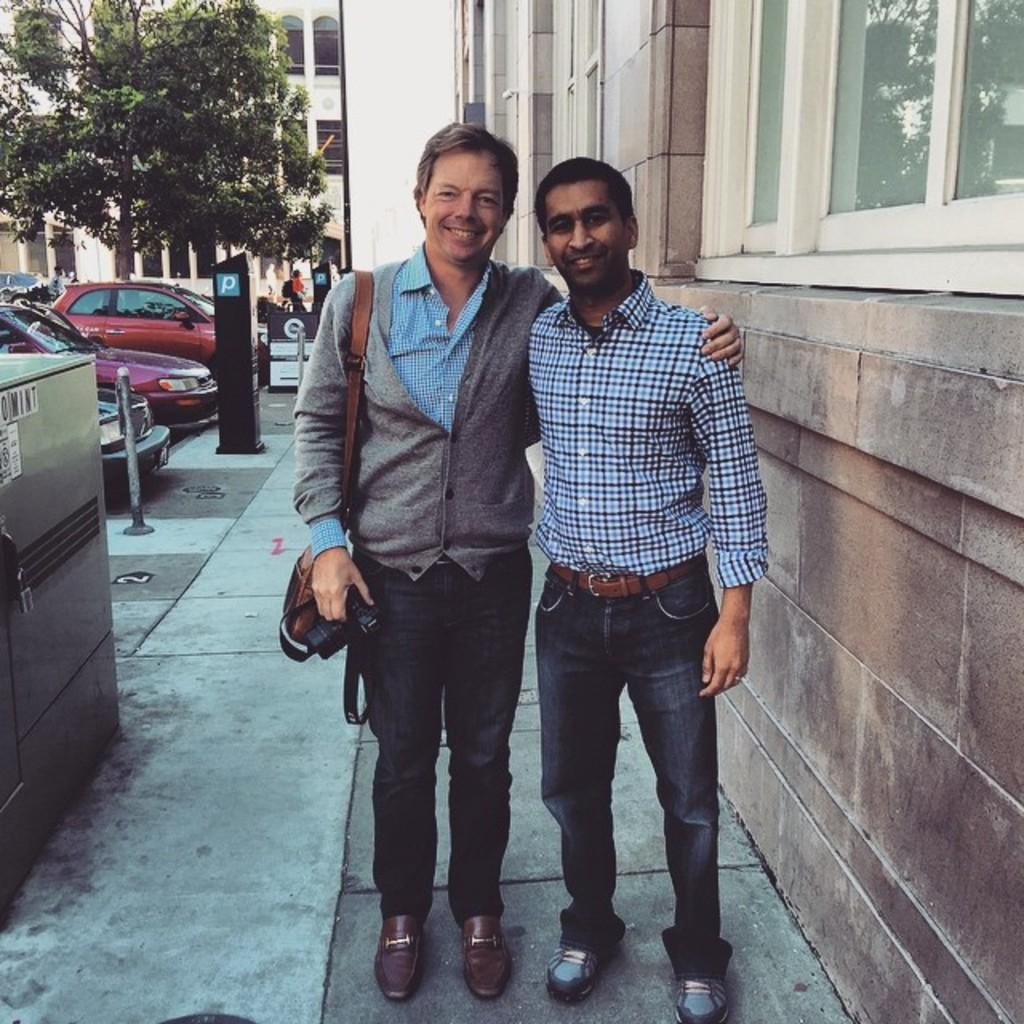How many people are in the image? There are two people standing on the ground in the image. What is the facial expression of the people in the image? The people are smiling. What can be seen in the background of the image? There are buildings, trees, and vehicles in the background of the image. What type of stocking is the person wearing on their head in the image? There is no person wearing a stocking on their head in the image. 